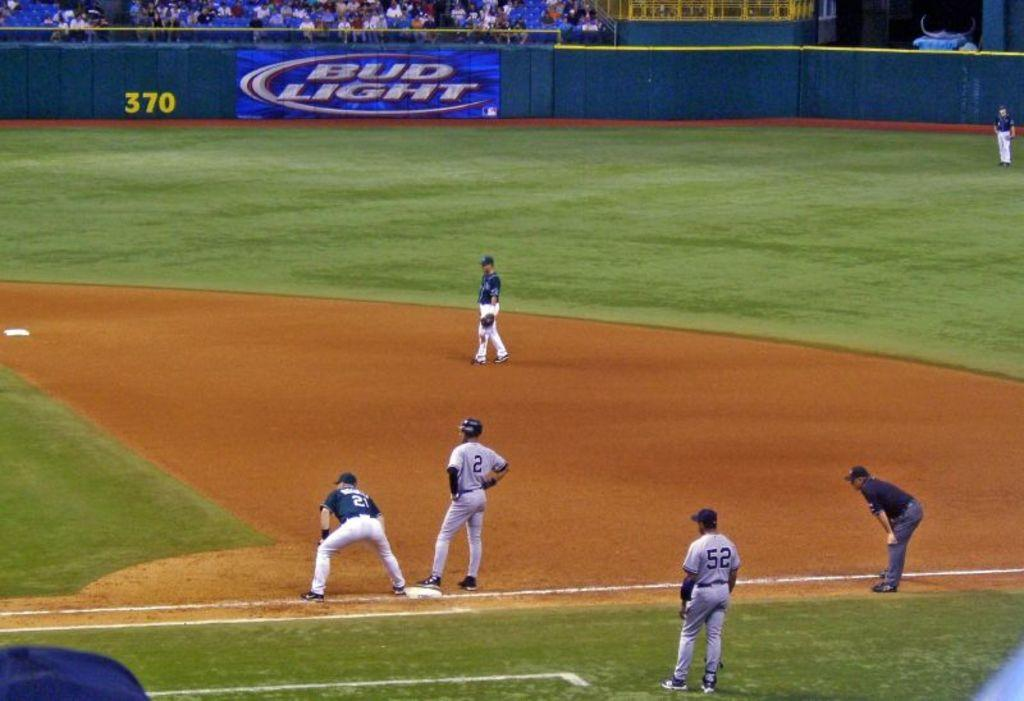<image>
Describe the image concisely. A Bud Light sign sits in the outfield of the ball field. 